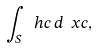Convert formula to latex. <formula><loc_0><loc_0><loc_500><loc_500>\int _ { S } \ h c \, d \ x c ,</formula> 